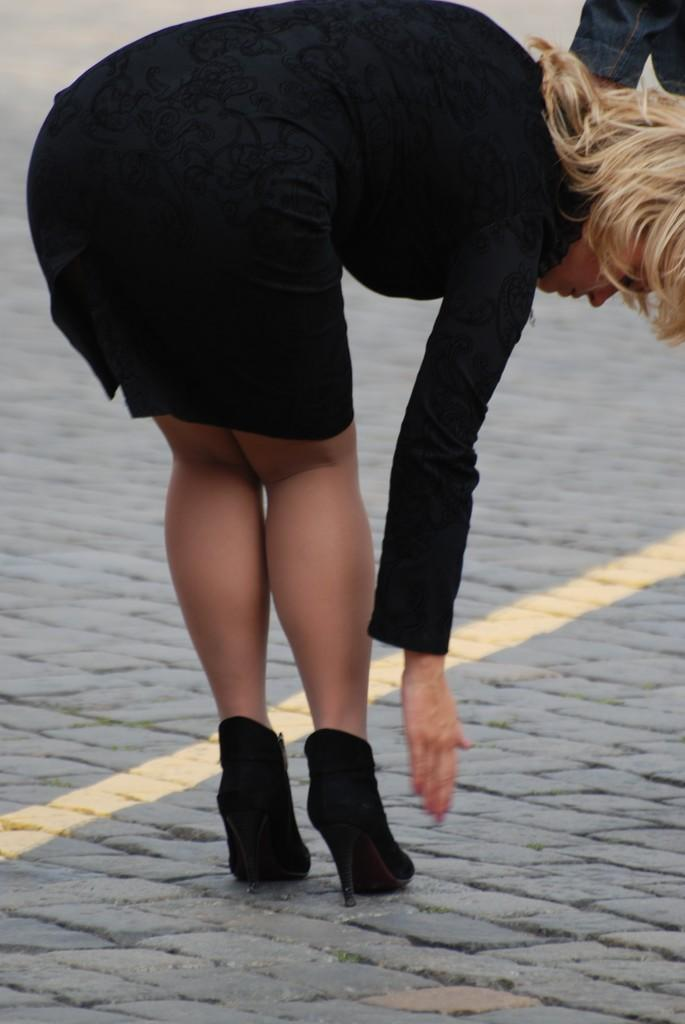Who is the main subject in the image? There is a woman in the image. What is the woman wearing on her lower body? The woman is wearing a black skirt. What type of footwear is the woman wearing? The woman is wearing black shoes. What is the woman doing in the image? The woman is bending on the floor. What is the woman thinking about while bending on the floor in the image? The image does not provide any information about the woman's thoughts, so we cannot determine what she might be thinking. 